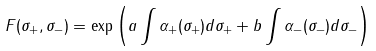Convert formula to latex. <formula><loc_0><loc_0><loc_500><loc_500>F ( \sigma _ { + } , \sigma _ { - } ) = \exp \left ( a \int \alpha _ { + } ( \sigma _ { + } ) d \sigma _ { + } + b \int \alpha _ { - } ( \sigma _ { - } ) d \sigma _ { - } \right )</formula> 